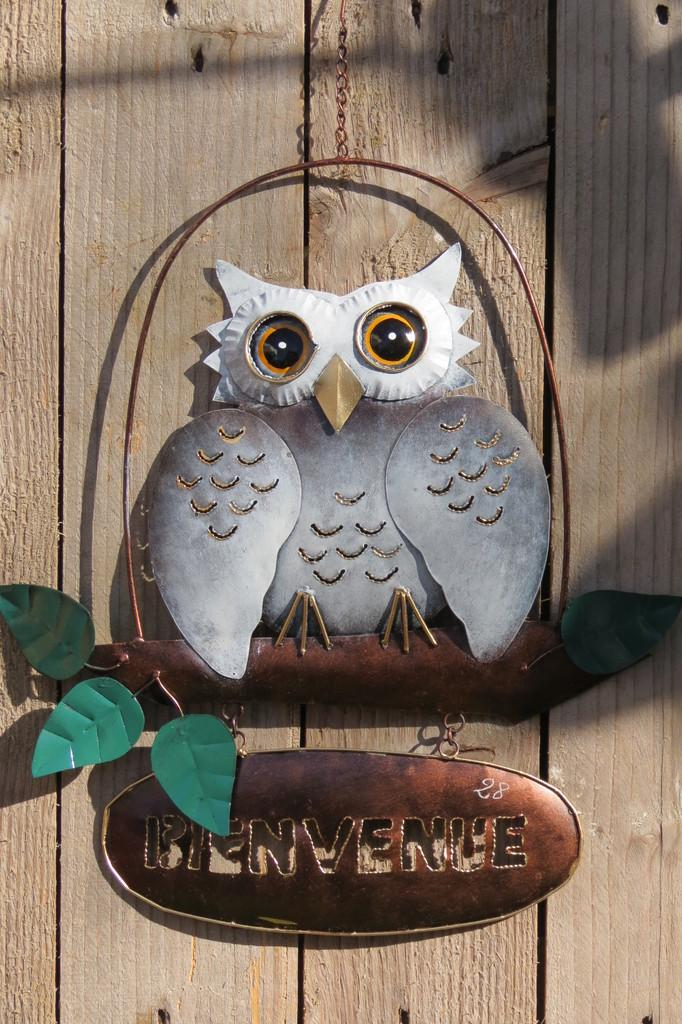What type of wall hanging is present in the image? There is an owl wall hanging in the image. What is the wall made of that the wall hanging is attached to? The wall hanging is hanged on a wooden wall. What else can be seen in the image besides the owl wall hanging? There is a board with text in the image. What grade did the owl receive for its performance in the image? There is no indication of a performance or grade in the image; it features an owl wall hanging on a wooden wall with a board displaying text. 